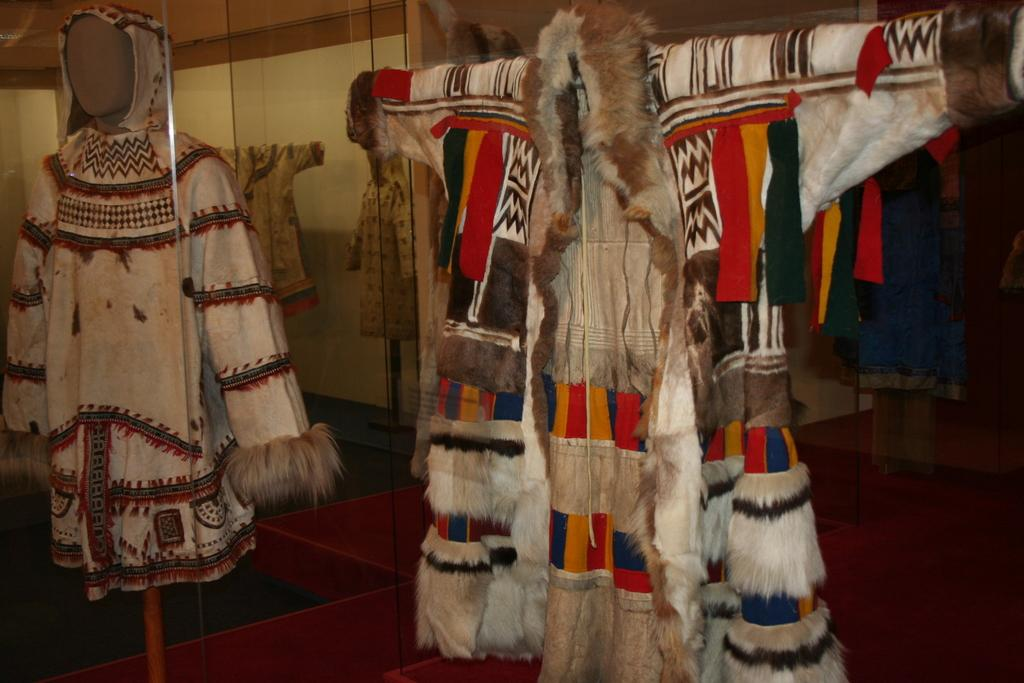What type of figures are present in the image? There are mannequins in the image. What are the mannequins wearing? Clothes are placed on the mannequins. What can be seen in the background of the image? There is a wall in the background of the image. What is visible at the bottom of the image? There is a floor visible at the bottom of the image. How many icicles are hanging from the mannequins in the image? There are no icicles present in the image; it features mannequins with clothes on them. Is there a stream visible in the image? There is no stream present in the image. 